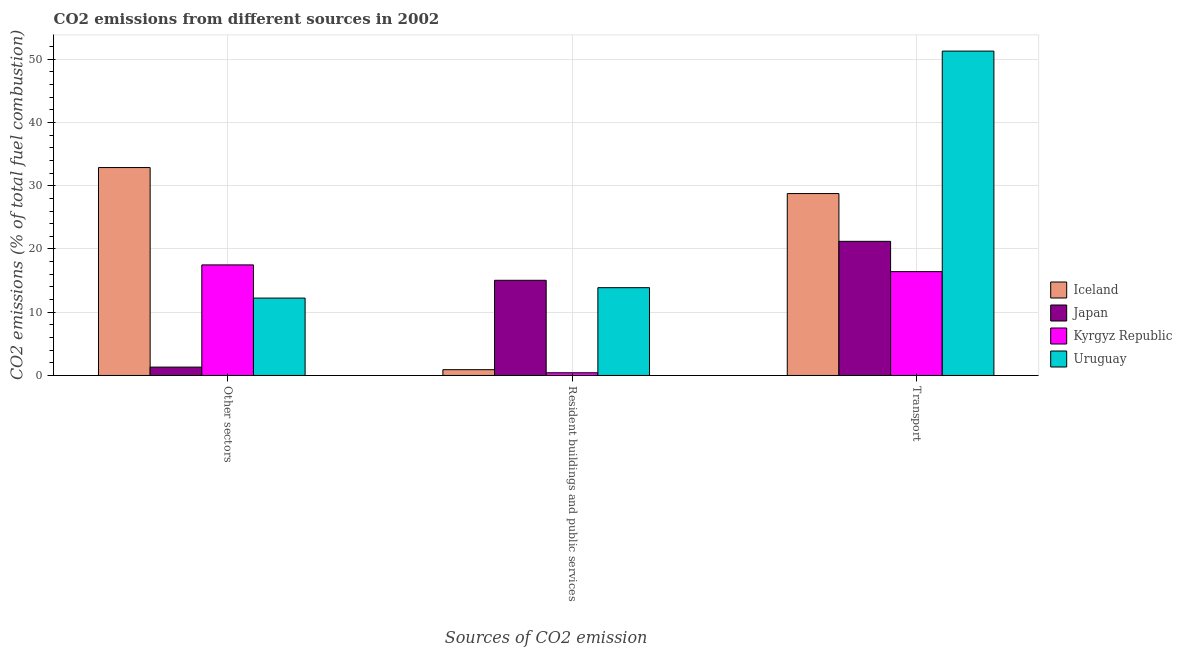How many different coloured bars are there?
Offer a terse response. 4. Are the number of bars on each tick of the X-axis equal?
Make the answer very short. Yes. What is the label of the 3rd group of bars from the left?
Your response must be concise. Transport. What is the percentage of co2 emissions from transport in Iceland?
Your answer should be very brief. 28.77. Across all countries, what is the maximum percentage of co2 emissions from resident buildings and public services?
Provide a short and direct response. 15.05. Across all countries, what is the minimum percentage of co2 emissions from transport?
Offer a very short reply. 16.42. In which country was the percentage of co2 emissions from other sectors maximum?
Give a very brief answer. Iceland. In which country was the percentage of co2 emissions from other sectors minimum?
Make the answer very short. Japan. What is the total percentage of co2 emissions from resident buildings and public services in the graph?
Give a very brief answer. 30.27. What is the difference between the percentage of co2 emissions from transport in Kyrgyz Republic and that in Uruguay?
Keep it short and to the point. -34.88. What is the difference between the percentage of co2 emissions from resident buildings and public services in Uruguay and the percentage of co2 emissions from transport in Iceland?
Offer a very short reply. -14.88. What is the average percentage of co2 emissions from transport per country?
Offer a terse response. 29.42. What is the difference between the percentage of co2 emissions from other sectors and percentage of co2 emissions from transport in Uruguay?
Make the answer very short. -39.06. What is the ratio of the percentage of co2 emissions from other sectors in Uruguay to that in Kyrgyz Republic?
Keep it short and to the point. 0.7. Is the difference between the percentage of co2 emissions from transport in Japan and Iceland greater than the difference between the percentage of co2 emissions from resident buildings and public services in Japan and Iceland?
Provide a succinct answer. No. What is the difference between the highest and the second highest percentage of co2 emissions from resident buildings and public services?
Offer a terse response. 1.17. What is the difference between the highest and the lowest percentage of co2 emissions from other sectors?
Your answer should be compact. 31.56. In how many countries, is the percentage of co2 emissions from resident buildings and public services greater than the average percentage of co2 emissions from resident buildings and public services taken over all countries?
Provide a succinct answer. 2. Is the sum of the percentage of co2 emissions from other sectors in Japan and Kyrgyz Republic greater than the maximum percentage of co2 emissions from transport across all countries?
Your response must be concise. No. What does the 1st bar from the left in Transport represents?
Give a very brief answer. Iceland. What does the 1st bar from the right in Other sectors represents?
Your response must be concise. Uruguay. Is it the case that in every country, the sum of the percentage of co2 emissions from other sectors and percentage of co2 emissions from resident buildings and public services is greater than the percentage of co2 emissions from transport?
Make the answer very short. No. How many bars are there?
Your answer should be compact. 12. How many countries are there in the graph?
Your answer should be compact. 4. What is the difference between two consecutive major ticks on the Y-axis?
Keep it short and to the point. 10. Does the graph contain any zero values?
Keep it short and to the point. No. How are the legend labels stacked?
Give a very brief answer. Vertical. What is the title of the graph?
Your response must be concise. CO2 emissions from different sources in 2002. Does "Belgium" appear as one of the legend labels in the graph?
Provide a short and direct response. No. What is the label or title of the X-axis?
Provide a succinct answer. Sources of CO2 emission. What is the label or title of the Y-axis?
Your answer should be very brief. CO2 emissions (% of total fuel combustion). What is the CO2 emissions (% of total fuel combustion) in Iceland in Other sectors?
Provide a succinct answer. 32.88. What is the CO2 emissions (% of total fuel combustion) in Japan in Other sectors?
Make the answer very short. 1.32. What is the CO2 emissions (% of total fuel combustion) in Kyrgyz Republic in Other sectors?
Keep it short and to the point. 17.48. What is the CO2 emissions (% of total fuel combustion) of Uruguay in Other sectors?
Your answer should be compact. 12.24. What is the CO2 emissions (% of total fuel combustion) of Iceland in Resident buildings and public services?
Your answer should be compact. 0.91. What is the CO2 emissions (% of total fuel combustion) of Japan in Resident buildings and public services?
Offer a very short reply. 15.05. What is the CO2 emissions (% of total fuel combustion) in Kyrgyz Republic in Resident buildings and public services?
Give a very brief answer. 0.43. What is the CO2 emissions (% of total fuel combustion) in Uruguay in Resident buildings and public services?
Give a very brief answer. 13.88. What is the CO2 emissions (% of total fuel combustion) in Iceland in Transport?
Offer a very short reply. 28.77. What is the CO2 emissions (% of total fuel combustion) of Japan in Transport?
Your answer should be compact. 21.21. What is the CO2 emissions (% of total fuel combustion) in Kyrgyz Republic in Transport?
Your answer should be very brief. 16.42. What is the CO2 emissions (% of total fuel combustion) in Uruguay in Transport?
Your answer should be compact. 51.29. Across all Sources of CO2 emission, what is the maximum CO2 emissions (% of total fuel combustion) in Iceland?
Make the answer very short. 32.88. Across all Sources of CO2 emission, what is the maximum CO2 emissions (% of total fuel combustion) in Japan?
Your answer should be very brief. 21.21. Across all Sources of CO2 emission, what is the maximum CO2 emissions (% of total fuel combustion) of Kyrgyz Republic?
Offer a terse response. 17.48. Across all Sources of CO2 emission, what is the maximum CO2 emissions (% of total fuel combustion) in Uruguay?
Offer a terse response. 51.29. Across all Sources of CO2 emission, what is the minimum CO2 emissions (% of total fuel combustion) of Iceland?
Your response must be concise. 0.91. Across all Sources of CO2 emission, what is the minimum CO2 emissions (% of total fuel combustion) of Japan?
Your answer should be compact. 1.32. Across all Sources of CO2 emission, what is the minimum CO2 emissions (% of total fuel combustion) in Kyrgyz Republic?
Your answer should be compact. 0.43. Across all Sources of CO2 emission, what is the minimum CO2 emissions (% of total fuel combustion) of Uruguay?
Your response must be concise. 12.24. What is the total CO2 emissions (% of total fuel combustion) of Iceland in the graph?
Provide a short and direct response. 62.56. What is the total CO2 emissions (% of total fuel combustion) of Japan in the graph?
Keep it short and to the point. 37.58. What is the total CO2 emissions (% of total fuel combustion) of Kyrgyz Republic in the graph?
Your answer should be very brief. 34.33. What is the total CO2 emissions (% of total fuel combustion) in Uruguay in the graph?
Your response must be concise. 77.41. What is the difference between the CO2 emissions (% of total fuel combustion) in Iceland in Other sectors and that in Resident buildings and public services?
Make the answer very short. 31.96. What is the difference between the CO2 emissions (% of total fuel combustion) of Japan in Other sectors and that in Resident buildings and public services?
Offer a terse response. -13.73. What is the difference between the CO2 emissions (% of total fuel combustion) of Kyrgyz Republic in Other sectors and that in Resident buildings and public services?
Your answer should be compact. 17.06. What is the difference between the CO2 emissions (% of total fuel combustion) in Uruguay in Other sectors and that in Resident buildings and public services?
Offer a terse response. -1.65. What is the difference between the CO2 emissions (% of total fuel combustion) in Iceland in Other sectors and that in Transport?
Your response must be concise. 4.11. What is the difference between the CO2 emissions (% of total fuel combustion) in Japan in Other sectors and that in Transport?
Offer a terse response. -19.89. What is the difference between the CO2 emissions (% of total fuel combustion) in Kyrgyz Republic in Other sectors and that in Transport?
Provide a succinct answer. 1.07. What is the difference between the CO2 emissions (% of total fuel combustion) of Uruguay in Other sectors and that in Transport?
Your answer should be very brief. -39.06. What is the difference between the CO2 emissions (% of total fuel combustion) of Iceland in Resident buildings and public services and that in Transport?
Provide a succinct answer. -27.85. What is the difference between the CO2 emissions (% of total fuel combustion) of Japan in Resident buildings and public services and that in Transport?
Keep it short and to the point. -6.16. What is the difference between the CO2 emissions (% of total fuel combustion) in Kyrgyz Republic in Resident buildings and public services and that in Transport?
Provide a short and direct response. -15.99. What is the difference between the CO2 emissions (% of total fuel combustion) in Uruguay in Resident buildings and public services and that in Transport?
Offer a very short reply. -37.41. What is the difference between the CO2 emissions (% of total fuel combustion) in Iceland in Other sectors and the CO2 emissions (% of total fuel combustion) in Japan in Resident buildings and public services?
Your answer should be very brief. 17.83. What is the difference between the CO2 emissions (% of total fuel combustion) of Iceland in Other sectors and the CO2 emissions (% of total fuel combustion) of Kyrgyz Republic in Resident buildings and public services?
Your response must be concise. 32.45. What is the difference between the CO2 emissions (% of total fuel combustion) in Iceland in Other sectors and the CO2 emissions (% of total fuel combustion) in Uruguay in Resident buildings and public services?
Your answer should be very brief. 18.99. What is the difference between the CO2 emissions (% of total fuel combustion) of Japan in Other sectors and the CO2 emissions (% of total fuel combustion) of Kyrgyz Republic in Resident buildings and public services?
Give a very brief answer. 0.89. What is the difference between the CO2 emissions (% of total fuel combustion) of Japan in Other sectors and the CO2 emissions (% of total fuel combustion) of Uruguay in Resident buildings and public services?
Make the answer very short. -12.56. What is the difference between the CO2 emissions (% of total fuel combustion) in Kyrgyz Republic in Other sectors and the CO2 emissions (% of total fuel combustion) in Uruguay in Resident buildings and public services?
Keep it short and to the point. 3.6. What is the difference between the CO2 emissions (% of total fuel combustion) of Iceland in Other sectors and the CO2 emissions (% of total fuel combustion) of Japan in Transport?
Provide a succinct answer. 11.67. What is the difference between the CO2 emissions (% of total fuel combustion) in Iceland in Other sectors and the CO2 emissions (% of total fuel combustion) in Kyrgyz Republic in Transport?
Give a very brief answer. 16.46. What is the difference between the CO2 emissions (% of total fuel combustion) in Iceland in Other sectors and the CO2 emissions (% of total fuel combustion) in Uruguay in Transport?
Give a very brief answer. -18.42. What is the difference between the CO2 emissions (% of total fuel combustion) in Japan in Other sectors and the CO2 emissions (% of total fuel combustion) in Kyrgyz Republic in Transport?
Keep it short and to the point. -15.1. What is the difference between the CO2 emissions (% of total fuel combustion) in Japan in Other sectors and the CO2 emissions (% of total fuel combustion) in Uruguay in Transport?
Offer a very short reply. -49.97. What is the difference between the CO2 emissions (% of total fuel combustion) in Kyrgyz Republic in Other sectors and the CO2 emissions (% of total fuel combustion) in Uruguay in Transport?
Your answer should be compact. -33.81. What is the difference between the CO2 emissions (% of total fuel combustion) of Iceland in Resident buildings and public services and the CO2 emissions (% of total fuel combustion) of Japan in Transport?
Give a very brief answer. -20.3. What is the difference between the CO2 emissions (% of total fuel combustion) in Iceland in Resident buildings and public services and the CO2 emissions (% of total fuel combustion) in Kyrgyz Republic in Transport?
Ensure brevity in your answer.  -15.5. What is the difference between the CO2 emissions (% of total fuel combustion) of Iceland in Resident buildings and public services and the CO2 emissions (% of total fuel combustion) of Uruguay in Transport?
Offer a very short reply. -50.38. What is the difference between the CO2 emissions (% of total fuel combustion) of Japan in Resident buildings and public services and the CO2 emissions (% of total fuel combustion) of Kyrgyz Republic in Transport?
Provide a short and direct response. -1.37. What is the difference between the CO2 emissions (% of total fuel combustion) of Japan in Resident buildings and public services and the CO2 emissions (% of total fuel combustion) of Uruguay in Transport?
Ensure brevity in your answer.  -36.24. What is the difference between the CO2 emissions (% of total fuel combustion) in Kyrgyz Republic in Resident buildings and public services and the CO2 emissions (% of total fuel combustion) in Uruguay in Transport?
Your response must be concise. -50.87. What is the average CO2 emissions (% of total fuel combustion) of Iceland per Sources of CO2 emission?
Offer a very short reply. 20.85. What is the average CO2 emissions (% of total fuel combustion) in Japan per Sources of CO2 emission?
Ensure brevity in your answer.  12.53. What is the average CO2 emissions (% of total fuel combustion) in Kyrgyz Republic per Sources of CO2 emission?
Your response must be concise. 11.44. What is the average CO2 emissions (% of total fuel combustion) of Uruguay per Sources of CO2 emission?
Give a very brief answer. 25.8. What is the difference between the CO2 emissions (% of total fuel combustion) in Iceland and CO2 emissions (% of total fuel combustion) in Japan in Other sectors?
Provide a succinct answer. 31.56. What is the difference between the CO2 emissions (% of total fuel combustion) of Iceland and CO2 emissions (% of total fuel combustion) of Kyrgyz Republic in Other sectors?
Your answer should be compact. 15.39. What is the difference between the CO2 emissions (% of total fuel combustion) in Iceland and CO2 emissions (% of total fuel combustion) in Uruguay in Other sectors?
Your answer should be very brief. 20.64. What is the difference between the CO2 emissions (% of total fuel combustion) of Japan and CO2 emissions (% of total fuel combustion) of Kyrgyz Republic in Other sectors?
Keep it short and to the point. -16.16. What is the difference between the CO2 emissions (% of total fuel combustion) of Japan and CO2 emissions (% of total fuel combustion) of Uruguay in Other sectors?
Keep it short and to the point. -10.91. What is the difference between the CO2 emissions (% of total fuel combustion) of Kyrgyz Republic and CO2 emissions (% of total fuel combustion) of Uruguay in Other sectors?
Provide a short and direct response. 5.25. What is the difference between the CO2 emissions (% of total fuel combustion) in Iceland and CO2 emissions (% of total fuel combustion) in Japan in Resident buildings and public services?
Provide a succinct answer. -14.14. What is the difference between the CO2 emissions (% of total fuel combustion) of Iceland and CO2 emissions (% of total fuel combustion) of Kyrgyz Republic in Resident buildings and public services?
Offer a very short reply. 0.49. What is the difference between the CO2 emissions (% of total fuel combustion) in Iceland and CO2 emissions (% of total fuel combustion) in Uruguay in Resident buildings and public services?
Your answer should be compact. -12.97. What is the difference between the CO2 emissions (% of total fuel combustion) of Japan and CO2 emissions (% of total fuel combustion) of Kyrgyz Republic in Resident buildings and public services?
Ensure brevity in your answer.  14.62. What is the difference between the CO2 emissions (% of total fuel combustion) of Japan and CO2 emissions (% of total fuel combustion) of Uruguay in Resident buildings and public services?
Give a very brief answer. 1.17. What is the difference between the CO2 emissions (% of total fuel combustion) of Kyrgyz Republic and CO2 emissions (% of total fuel combustion) of Uruguay in Resident buildings and public services?
Your answer should be very brief. -13.46. What is the difference between the CO2 emissions (% of total fuel combustion) of Iceland and CO2 emissions (% of total fuel combustion) of Japan in Transport?
Your answer should be very brief. 7.56. What is the difference between the CO2 emissions (% of total fuel combustion) of Iceland and CO2 emissions (% of total fuel combustion) of Kyrgyz Republic in Transport?
Offer a very short reply. 12.35. What is the difference between the CO2 emissions (% of total fuel combustion) in Iceland and CO2 emissions (% of total fuel combustion) in Uruguay in Transport?
Keep it short and to the point. -22.53. What is the difference between the CO2 emissions (% of total fuel combustion) of Japan and CO2 emissions (% of total fuel combustion) of Kyrgyz Republic in Transport?
Offer a very short reply. 4.79. What is the difference between the CO2 emissions (% of total fuel combustion) in Japan and CO2 emissions (% of total fuel combustion) in Uruguay in Transport?
Make the answer very short. -30.08. What is the difference between the CO2 emissions (% of total fuel combustion) in Kyrgyz Republic and CO2 emissions (% of total fuel combustion) in Uruguay in Transport?
Your answer should be compact. -34.88. What is the ratio of the CO2 emissions (% of total fuel combustion) of Iceland in Other sectors to that in Resident buildings and public services?
Keep it short and to the point. 36. What is the ratio of the CO2 emissions (% of total fuel combustion) in Japan in Other sectors to that in Resident buildings and public services?
Give a very brief answer. 0.09. What is the ratio of the CO2 emissions (% of total fuel combustion) in Uruguay in Other sectors to that in Resident buildings and public services?
Ensure brevity in your answer.  0.88. What is the ratio of the CO2 emissions (% of total fuel combustion) of Japan in Other sectors to that in Transport?
Give a very brief answer. 0.06. What is the ratio of the CO2 emissions (% of total fuel combustion) of Kyrgyz Republic in Other sectors to that in Transport?
Ensure brevity in your answer.  1.06. What is the ratio of the CO2 emissions (% of total fuel combustion) of Uruguay in Other sectors to that in Transport?
Keep it short and to the point. 0.24. What is the ratio of the CO2 emissions (% of total fuel combustion) in Iceland in Resident buildings and public services to that in Transport?
Provide a short and direct response. 0.03. What is the ratio of the CO2 emissions (% of total fuel combustion) of Japan in Resident buildings and public services to that in Transport?
Provide a succinct answer. 0.71. What is the ratio of the CO2 emissions (% of total fuel combustion) in Kyrgyz Republic in Resident buildings and public services to that in Transport?
Your answer should be compact. 0.03. What is the ratio of the CO2 emissions (% of total fuel combustion) in Uruguay in Resident buildings and public services to that in Transport?
Make the answer very short. 0.27. What is the difference between the highest and the second highest CO2 emissions (% of total fuel combustion) in Iceland?
Offer a very short reply. 4.11. What is the difference between the highest and the second highest CO2 emissions (% of total fuel combustion) of Japan?
Keep it short and to the point. 6.16. What is the difference between the highest and the second highest CO2 emissions (% of total fuel combustion) of Kyrgyz Republic?
Keep it short and to the point. 1.07. What is the difference between the highest and the second highest CO2 emissions (% of total fuel combustion) in Uruguay?
Provide a succinct answer. 37.41. What is the difference between the highest and the lowest CO2 emissions (% of total fuel combustion) in Iceland?
Make the answer very short. 31.96. What is the difference between the highest and the lowest CO2 emissions (% of total fuel combustion) of Japan?
Provide a succinct answer. 19.89. What is the difference between the highest and the lowest CO2 emissions (% of total fuel combustion) in Kyrgyz Republic?
Provide a short and direct response. 17.06. What is the difference between the highest and the lowest CO2 emissions (% of total fuel combustion) in Uruguay?
Offer a terse response. 39.06. 